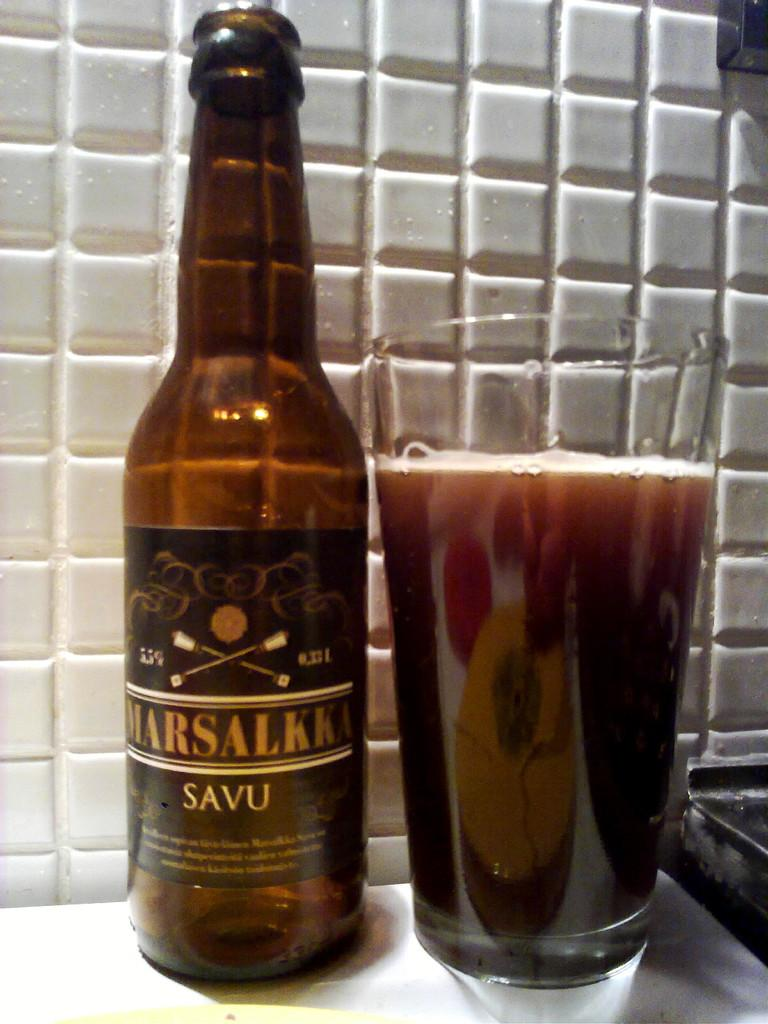<image>
Provide a brief description of the given image. The dark drink from the bottle has 5.5% alcohol content. 